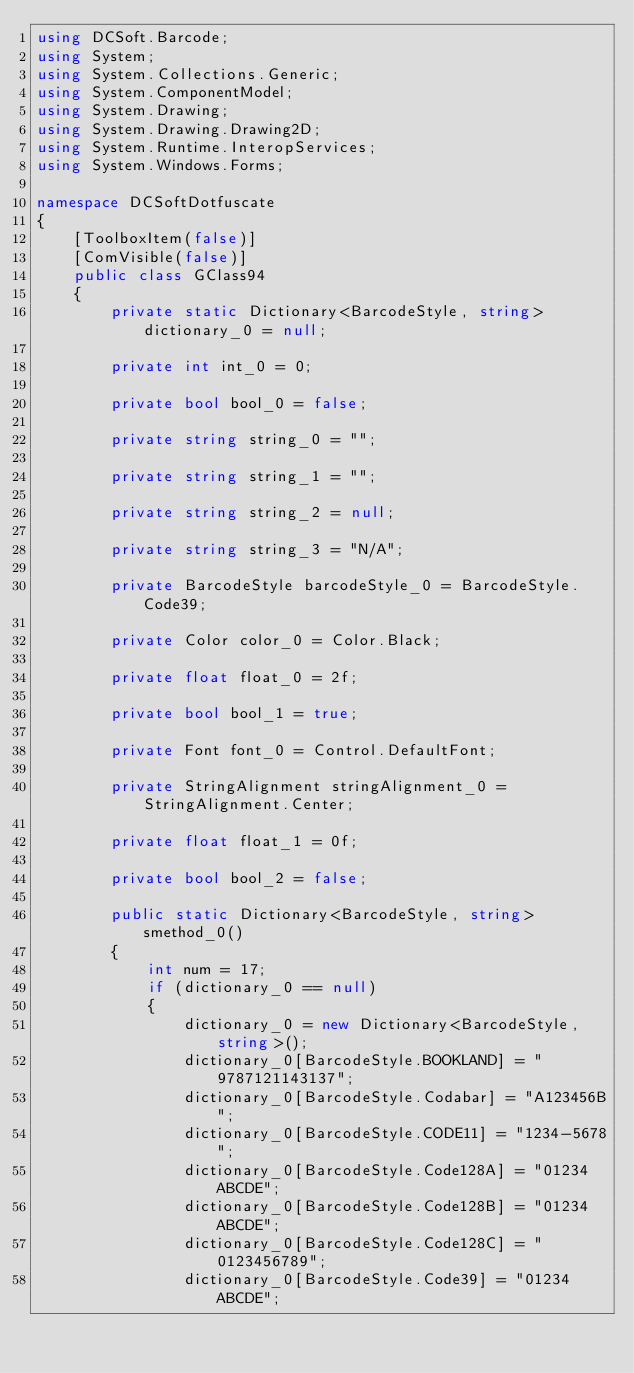Convert code to text. <code><loc_0><loc_0><loc_500><loc_500><_C#_>using DCSoft.Barcode;
using System;
using System.Collections.Generic;
using System.ComponentModel;
using System.Drawing;
using System.Drawing.Drawing2D;
using System.Runtime.InteropServices;
using System.Windows.Forms;

namespace DCSoftDotfuscate
{
	[ToolboxItem(false)]
	[ComVisible(false)]
	public class GClass94
	{
		private static Dictionary<BarcodeStyle, string> dictionary_0 = null;

		private int int_0 = 0;

		private bool bool_0 = false;

		private string string_0 = "";

		private string string_1 = "";

		private string string_2 = null;

		private string string_3 = "N/A";

		private BarcodeStyle barcodeStyle_0 = BarcodeStyle.Code39;

		private Color color_0 = Color.Black;

		private float float_0 = 2f;

		private bool bool_1 = true;

		private Font font_0 = Control.DefaultFont;

		private StringAlignment stringAlignment_0 = StringAlignment.Center;

		private float float_1 = 0f;

		private bool bool_2 = false;

		public static Dictionary<BarcodeStyle, string> smethod_0()
		{
			int num = 17;
			if (dictionary_0 == null)
			{
				dictionary_0 = new Dictionary<BarcodeStyle, string>();
				dictionary_0[BarcodeStyle.BOOKLAND] = "9787121143137";
				dictionary_0[BarcodeStyle.Codabar] = "A123456B";
				dictionary_0[BarcodeStyle.CODE11] = "1234-5678";
				dictionary_0[BarcodeStyle.Code128A] = "01234ABCDE";
				dictionary_0[BarcodeStyle.Code128B] = "01234ABCDE";
				dictionary_0[BarcodeStyle.Code128C] = "0123456789";
				dictionary_0[BarcodeStyle.Code39] = "01234ABCDE";</code> 